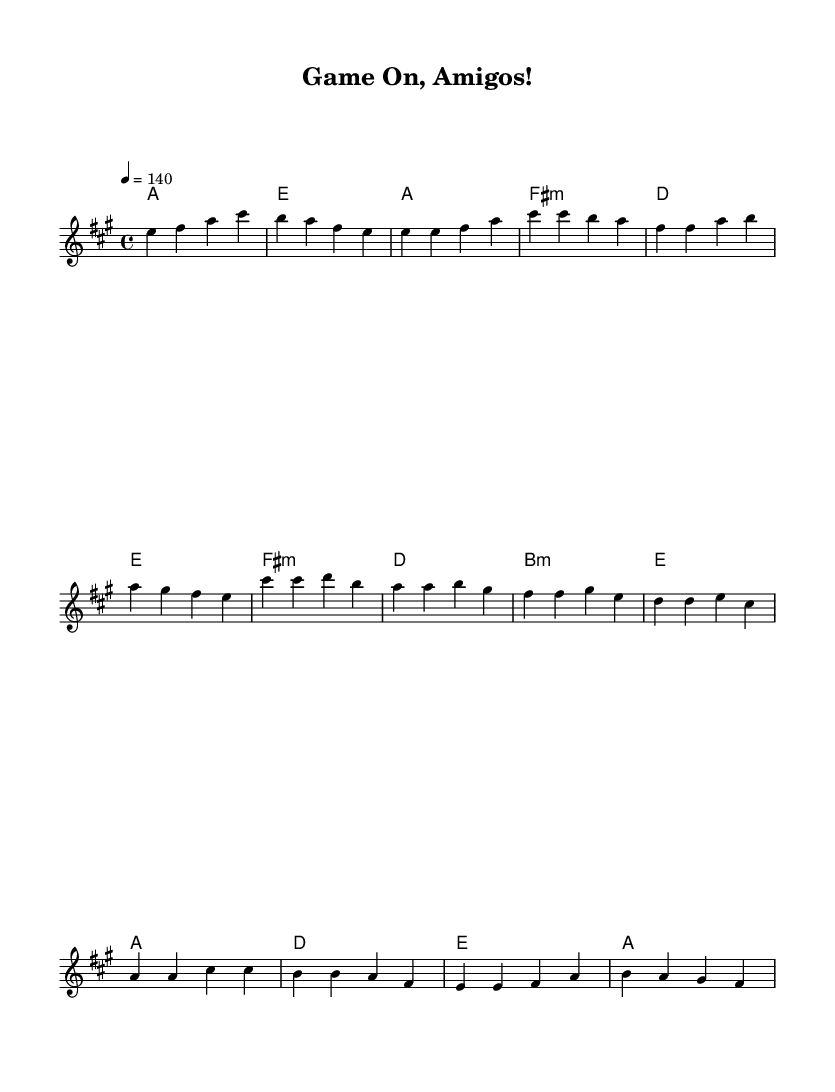What is the key signature of this music? The key signature is A major, which has three sharps: F#, C#, and G#. This can be determined from the information indicated in the `\key` directive of the LilyPond code, which specifies the music is in A major.
Answer: A major What is the time signature of this music? The time signature is 4/4, as defined in the `\time` directive of the LilyPond code. This indicates that there are four beats in each measure, and the quarter note receives one beat.
Answer: 4/4 What is the tempo marking for this piece? The tempo marking is 140 beats per minute, which can be found in the line marked `\tempo 4 = 140` in the code. This indicates the speed at which the music should be played.
Answer: 140 How many sections does the music have? The music is structured into four sections: Intro, Verse, Pre-Chorus, and Chorus, which can be inferred from the different labeled parts in the melody and harmony sections.
Answer: Four What is the main tonality of the piece? The main tonality of the piece is major, specifically A major, as indicated by the key signature and the overall sound of the chords used in the harmony section, which are typically uplifting and bright.
Answer: Major What chords are used during the Pre-Chorus section? The chords used during the Pre-Chorus section are F# minor, D major, B minor, and E major. This can be identified from the `\chordmode` section of the code where these chords are specified.
Answer: F# minor, D major, B minor, E major Which measure contains the first instance of the melody note E? The first instance of the melody note E appears in measure 1 of the melody part, indicated by the note written in the melody staff at the beginning of the music.
Answer: Measure 1 